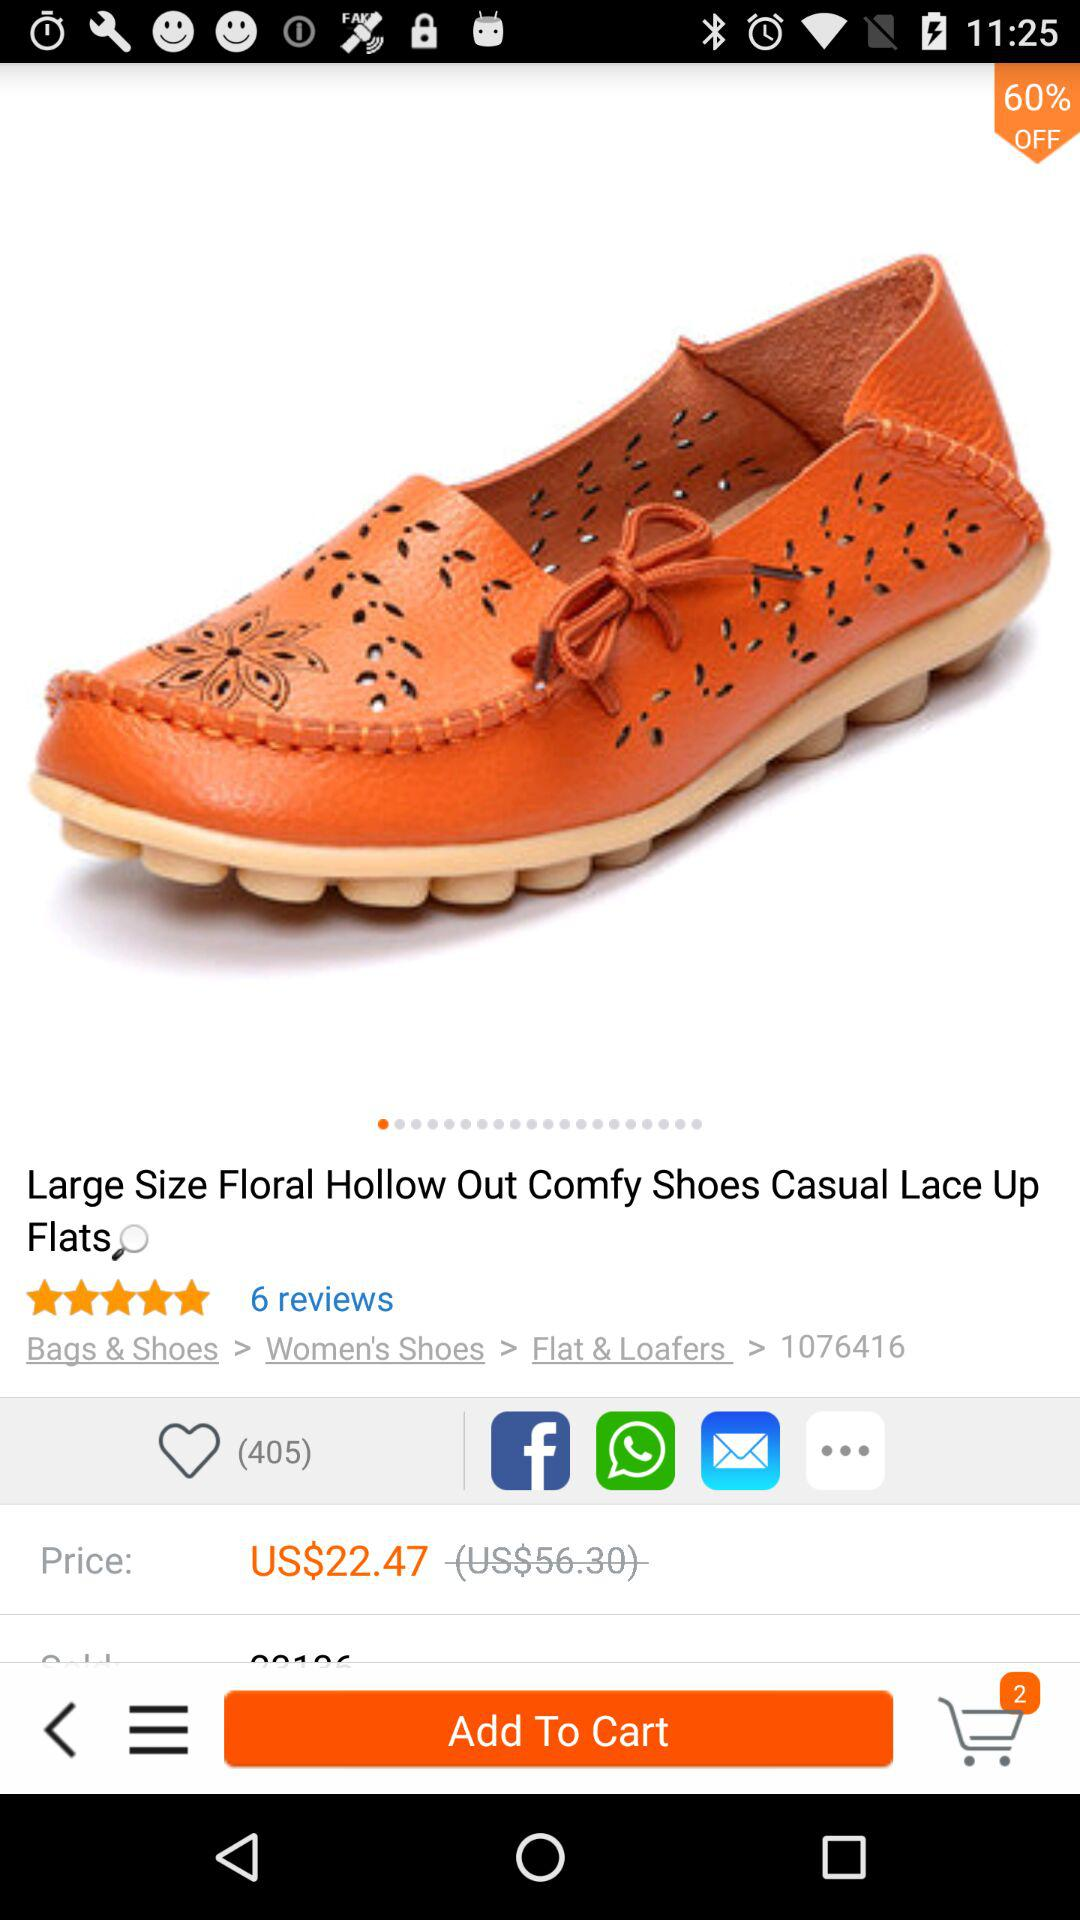How many reviews are given to casual lace-up flats? There are 6 reviews for casual lace-up flats. 